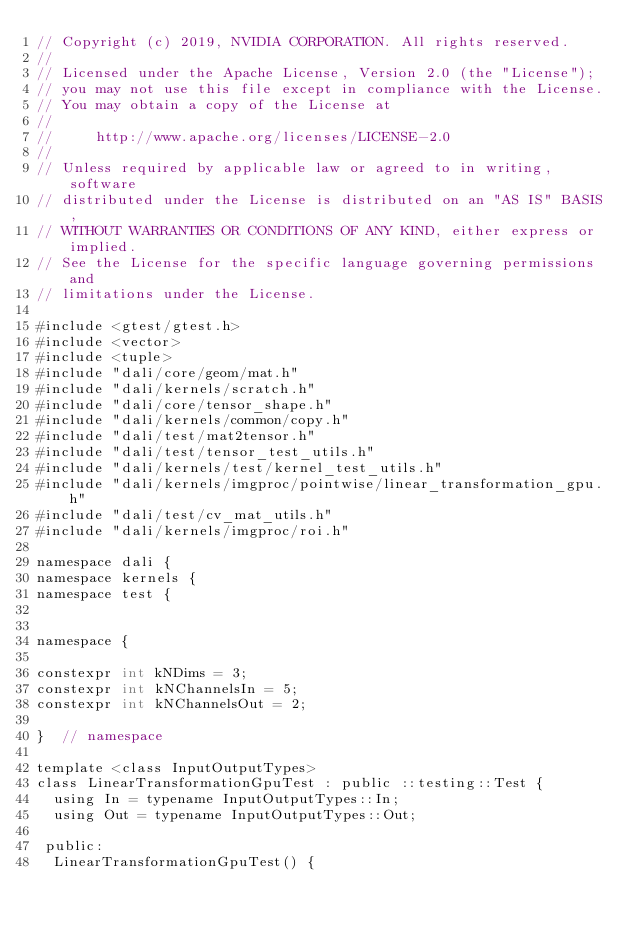<code> <loc_0><loc_0><loc_500><loc_500><_Cuda_>// Copyright (c) 2019, NVIDIA CORPORATION. All rights reserved.
//
// Licensed under the Apache License, Version 2.0 (the "License");
// you may not use this file except in compliance with the License.
// You may obtain a copy of the License at
//
//     http://www.apache.org/licenses/LICENSE-2.0
//
// Unless required by applicable law or agreed to in writing, software
// distributed under the License is distributed on an "AS IS" BASIS,
// WITHOUT WARRANTIES OR CONDITIONS OF ANY KIND, either express or implied.
// See the License for the specific language governing permissions and
// limitations under the License.

#include <gtest/gtest.h>
#include <vector>
#include <tuple>
#include "dali/core/geom/mat.h"
#include "dali/kernels/scratch.h"
#include "dali/core/tensor_shape.h"
#include "dali/kernels/common/copy.h"
#include "dali/test/mat2tensor.h"
#include "dali/test/tensor_test_utils.h"
#include "dali/kernels/test/kernel_test_utils.h"
#include "dali/kernels/imgproc/pointwise/linear_transformation_gpu.h"
#include "dali/test/cv_mat_utils.h"
#include "dali/kernels/imgproc/roi.h"

namespace dali {
namespace kernels {
namespace test {


namespace {

constexpr int kNDims = 3;
constexpr int kNChannelsIn = 5;
constexpr int kNChannelsOut = 2;

}  // namespace

template <class InputOutputTypes>
class LinearTransformationGpuTest : public ::testing::Test {
  using In = typename InputOutputTypes::In;
  using Out = typename InputOutputTypes::Out;

 public:
  LinearTransformationGpuTest() {</code> 